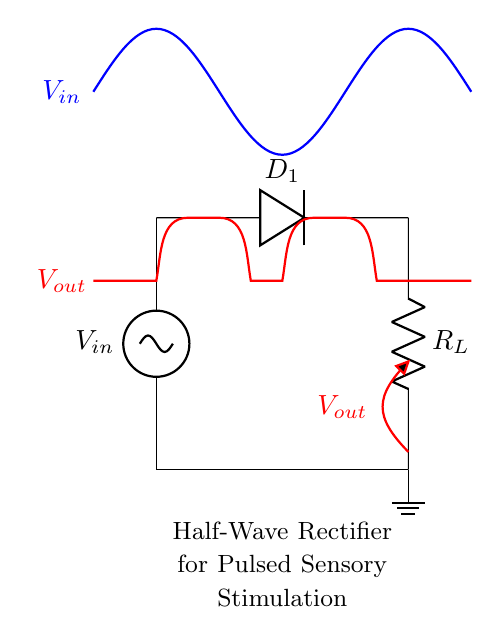What is the type of rectifier depicted in this circuit? The circuit is identified as a half-wave rectifier, which can be determined by the presence of a single diode allowing current in only one direction.
Answer: Half-wave rectifier What is the role of the diode in this circuit? The diode, labeled as D1, allows current to flow only in one direction, converting alternating current into direct current during the positive half of the input waveform.
Answer: Allow current in one direction What component represents the load in this circuit? The load resistor is represented by the component labeled R_L, which is connected to the output of the rectifier and absorbs the rectified voltage.
Answer: R_L What does the output voltage represent in this circuit? The output voltage, denoted as V_out, reflects the voltage available across the load resistor after rectification of the input AC signal, indicating the effective voltage delivered to the load.
Answer: V_out How does the output waveform compare to the input waveform? The output waveform is a pulsed waveform that follows the positive half-cycle of the input waveform while the negative half-cycle is blocked by the diode, resulting in gaps during the negative phase.
Answer: Pulsed waveform What happens to the current during the negative half-cycle of the input signal? During the negative half-cycle, the diode becomes reverse-biased and blocks the current flow, resulting in no output current being generated.
Answer: No current What is the purpose of this half-wave rectifier circuit in a sensory stimulation device? The half-wave rectifier circuit is used to provide pulsed electrical stimulation, facilitating sensory experiences through controlled, pulsed output rather than continuous output.
Answer: Pulsed sensory stimulation 